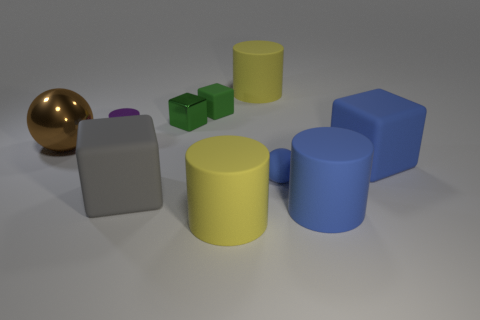Subtract all blue cylinders. How many cylinders are left? 3 Add 4 large blue matte blocks. How many large blue matte blocks exist? 5 Subtract all blue cylinders. How many cylinders are left? 3 Subtract 0 green spheres. How many objects are left? 10 Subtract all cubes. How many objects are left? 6 Subtract 2 cylinders. How many cylinders are left? 2 Subtract all yellow cylinders. Subtract all purple cubes. How many cylinders are left? 2 Subtract all cyan balls. How many yellow cylinders are left? 2 Subtract all yellow things. Subtract all large blue objects. How many objects are left? 6 Add 6 green cubes. How many green cubes are left? 8 